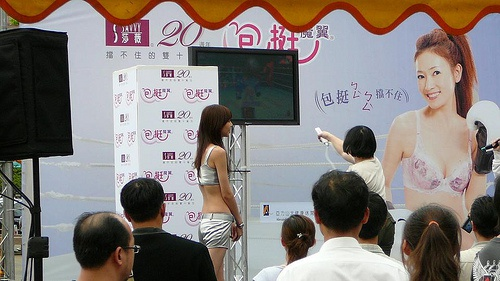Describe the objects in this image and their specific colors. I can see people in maroon, darkgray, tan, and brown tones, people in maroon, white, black, and gray tones, tv in maroon, black, gray, and purple tones, people in maroon, black, and lightgray tones, and people in maroon, black, gray, and darkgray tones in this image. 